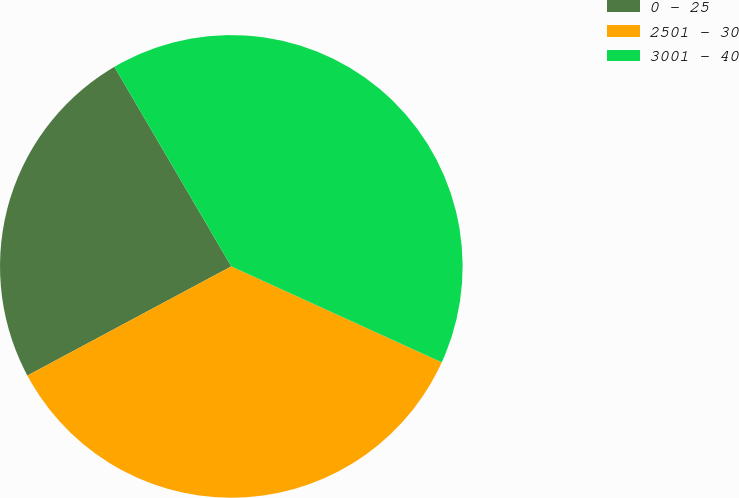Convert chart to OTSL. <chart><loc_0><loc_0><loc_500><loc_500><pie_chart><fcel>0 - 25<fcel>2501 - 30<fcel>3001 - 40<nl><fcel>24.39%<fcel>35.37%<fcel>40.24%<nl></chart> 